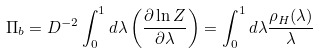<formula> <loc_0><loc_0><loc_500><loc_500>\Pi _ { b } = D ^ { - 2 } \int _ { 0 } ^ { 1 } d \lambda \left ( \frac { \partial \ln Z } { \partial \lambda } \right ) = \int _ { 0 } ^ { 1 } d \lambda \frac { \rho _ { H } ( \lambda ) } { \lambda }</formula> 